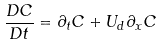<formula> <loc_0><loc_0><loc_500><loc_500>\frac { D C } { D t } = \partial _ { t } C + U _ { d } \partial _ { x } C</formula> 